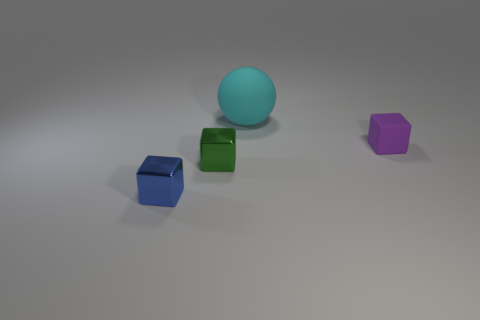Do the blue metallic thing and the metallic object right of the blue cube have the same size?
Keep it short and to the point. Yes. Is there a small metallic object that has the same color as the small rubber cube?
Provide a short and direct response. No. There is a purple object that is made of the same material as the sphere; what is its size?
Give a very brief answer. Small. Is the material of the tiny purple thing the same as the blue object?
Provide a succinct answer. No. What is the color of the small metal cube behind the small blue cube that is in front of the rubber thing to the left of the purple block?
Your response must be concise. Green. What is the shape of the big thing?
Provide a succinct answer. Sphere. There is a large rubber ball; is it the same color as the rubber thing that is right of the big cyan matte ball?
Your answer should be very brief. No. Are there the same number of rubber things behind the large cyan ball and large blue rubber cubes?
Your answer should be very brief. Yes. How many metallic objects are the same size as the purple matte thing?
Offer a very short reply. 2. Is there a tiny blue cylinder?
Your answer should be very brief. No. 